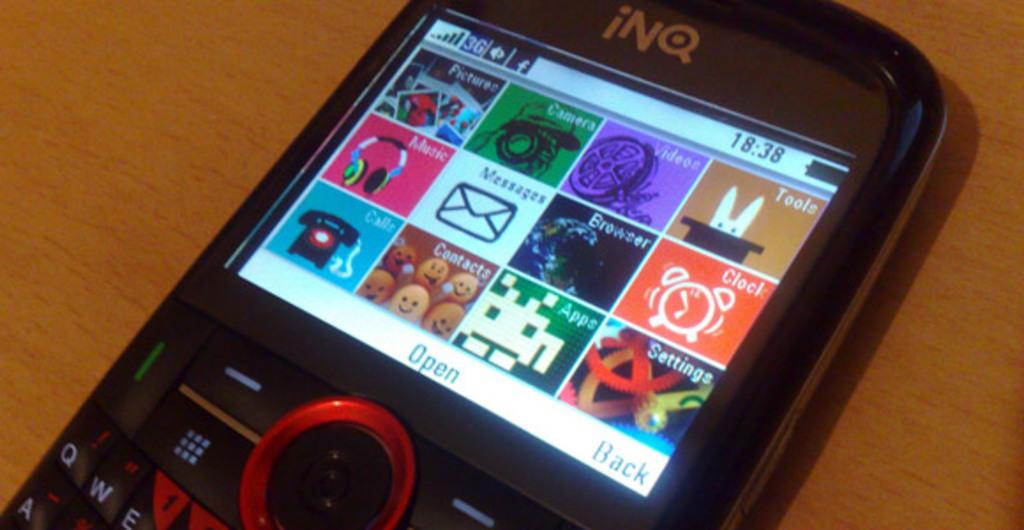What object is the main focus of the image? There is a mobile in the image. What type of surface is the mobile placed on? The mobile is placed on a wooden surface. How many dolls are sitting on the skate in the image? There are no dolls or skates present in the image; it only features a mobile on a wooden surface. 